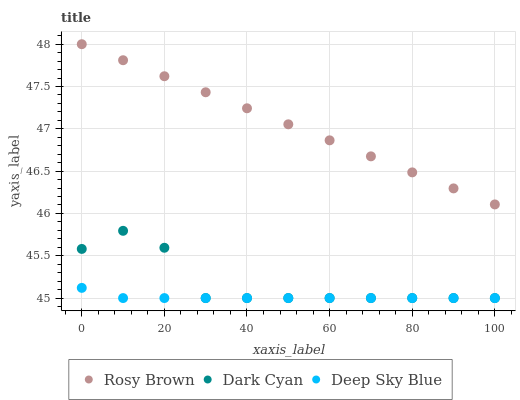Does Deep Sky Blue have the minimum area under the curve?
Answer yes or no. Yes. Does Rosy Brown have the maximum area under the curve?
Answer yes or no. Yes. Does Rosy Brown have the minimum area under the curve?
Answer yes or no. No. Does Deep Sky Blue have the maximum area under the curve?
Answer yes or no. No. Is Rosy Brown the smoothest?
Answer yes or no. Yes. Is Dark Cyan the roughest?
Answer yes or no. Yes. Is Deep Sky Blue the smoothest?
Answer yes or no. No. Is Deep Sky Blue the roughest?
Answer yes or no. No. Does Dark Cyan have the lowest value?
Answer yes or no. Yes. Does Rosy Brown have the lowest value?
Answer yes or no. No. Does Rosy Brown have the highest value?
Answer yes or no. Yes. Does Deep Sky Blue have the highest value?
Answer yes or no. No. Is Deep Sky Blue less than Rosy Brown?
Answer yes or no. Yes. Is Rosy Brown greater than Deep Sky Blue?
Answer yes or no. Yes. Does Dark Cyan intersect Deep Sky Blue?
Answer yes or no. Yes. Is Dark Cyan less than Deep Sky Blue?
Answer yes or no. No. Is Dark Cyan greater than Deep Sky Blue?
Answer yes or no. No. Does Deep Sky Blue intersect Rosy Brown?
Answer yes or no. No. 